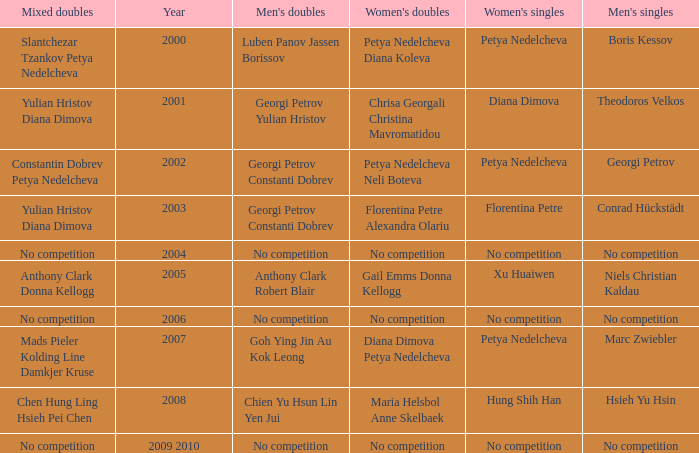Could you parse the entire table? {'header': ['Mixed doubles', 'Year', "Men's doubles", "Women's doubles", "Women's singles", "Men's singles"], 'rows': [['Slantchezar Tzankov Petya Nedelcheva', '2000', 'Luben Panov Jassen Borissov', 'Petya Nedelcheva Diana Koleva', 'Petya Nedelcheva', 'Boris Kessov'], ['Yulian Hristov Diana Dimova', '2001', 'Georgi Petrov Yulian Hristov', 'Chrisa Georgali Christina Mavromatidou', 'Diana Dimova', 'Theodoros Velkos'], ['Constantin Dobrev Petya Nedelcheva', '2002', 'Georgi Petrov Constanti Dobrev', 'Petya Nedelcheva Neli Boteva', 'Petya Nedelcheva', 'Georgi Petrov'], ['Yulian Hristov Diana Dimova', '2003', 'Georgi Petrov Constanti Dobrev', 'Florentina Petre Alexandra Olariu', 'Florentina Petre', 'Conrad Hückstädt'], ['No competition', '2004', 'No competition', 'No competition', 'No competition', 'No competition'], ['Anthony Clark Donna Kellogg', '2005', 'Anthony Clark Robert Blair', 'Gail Emms Donna Kellogg', 'Xu Huaiwen', 'Niels Christian Kaldau'], ['No competition', '2006', 'No competition', 'No competition', 'No competition', 'No competition'], ['Mads Pieler Kolding Line Damkjer Kruse', '2007', 'Goh Ying Jin Au Kok Leong', 'Diana Dimova Petya Nedelcheva', 'Petya Nedelcheva', 'Marc Zwiebler'], ['Chen Hung Ling Hsieh Pei Chen', '2008', 'Chien Yu Hsun Lin Yen Jui', 'Maria Helsbol Anne Skelbaek', 'Hung Shih Han', 'Hsieh Yu Hsin'], ['No competition', '2009 2010', 'No competition', 'No competition', 'No competition', 'No competition']]} Who won the Men's Double the same year as Florentina Petre winning the Women's Singles? Georgi Petrov Constanti Dobrev. 